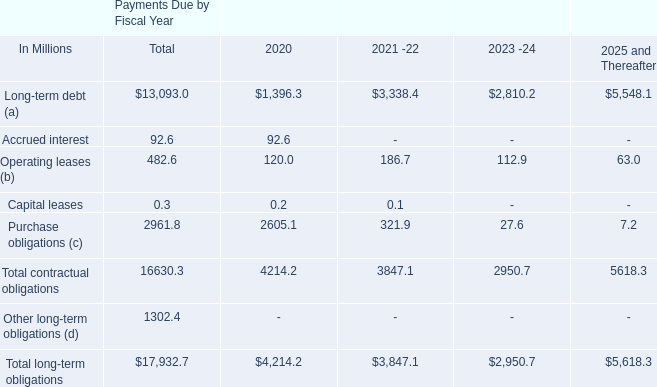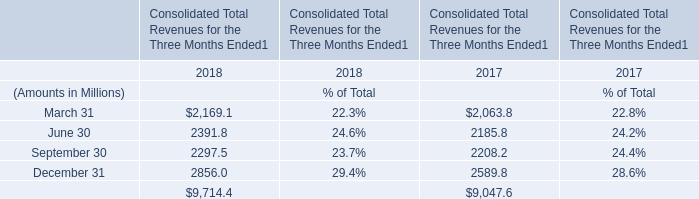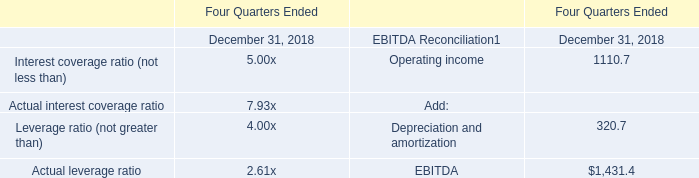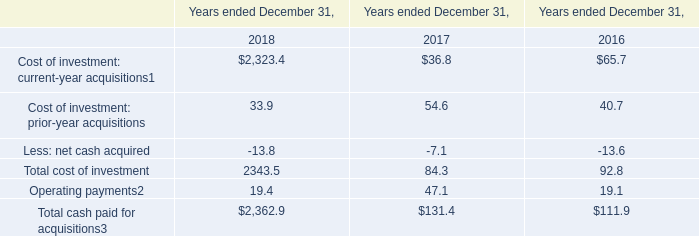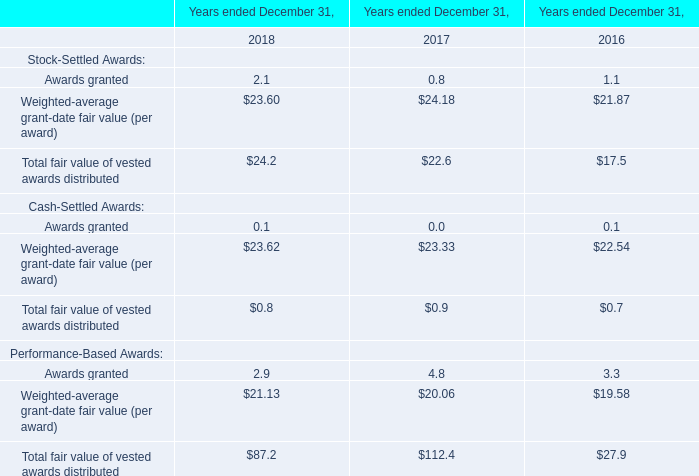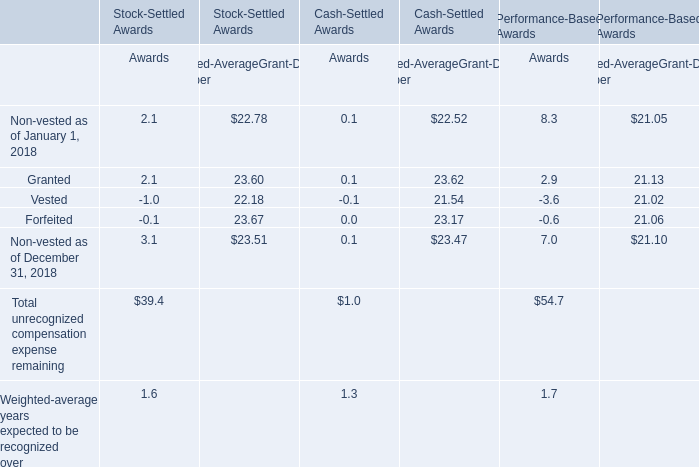In the section with the most Total unrecognized compensation expense remaining, what is the growth rate of Non-vested? (in %) 
Computations: ((7 - 8.3) / 8.3)
Answer: -0.15663. 